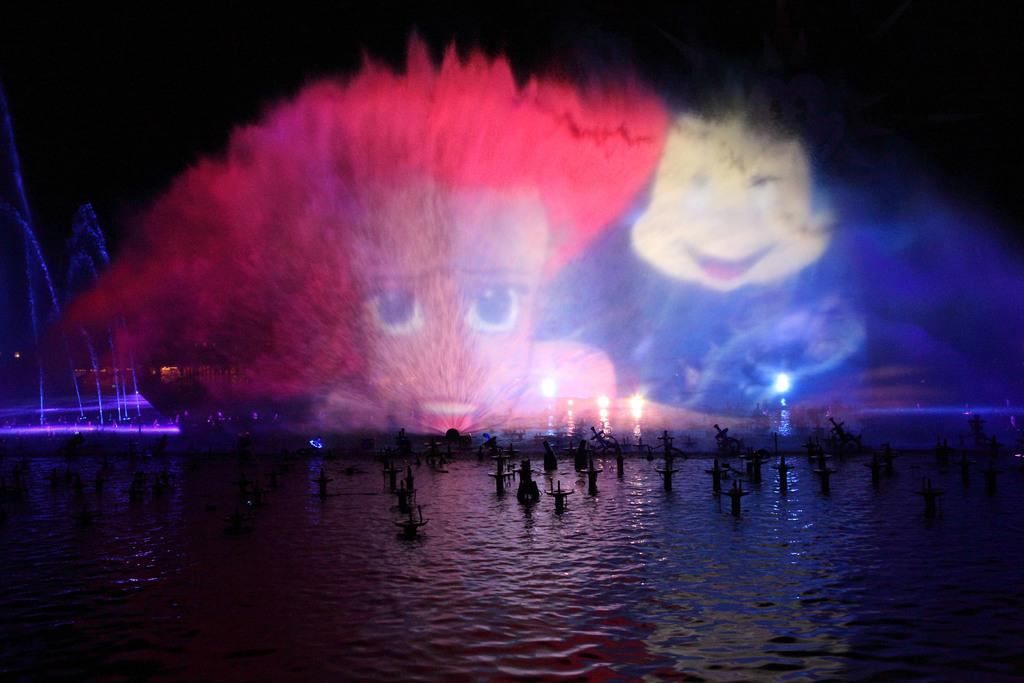What is in the front of the image? There is river water in the front of the image. What can be seen in the river water? There are wooden cross marks in the marks in the river water. What type of event or display is happening in the image? There is a laser light show in the image. What is featured in the laser light show? The laser light show features visual cartoon faces. What is the color of the background in the image? The background of the image is dark. Can you tell me who is holding the parcel in the image? There is no parcel present in the image. What color is the pencil used by the brother in the image? There is no brother or pencil present in the image. 